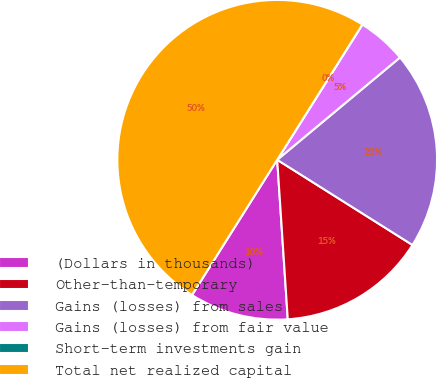Convert chart to OTSL. <chart><loc_0><loc_0><loc_500><loc_500><pie_chart><fcel>(Dollars in thousands)<fcel>Other-than-temporary<fcel>Gains (losses) from sales<fcel>Gains (losses) from fair value<fcel>Short-term investments gain<fcel>Total net realized capital<nl><fcel>10.0%<fcel>15.0%<fcel>20.0%<fcel>5.0%<fcel>0.0%<fcel>49.99%<nl></chart> 